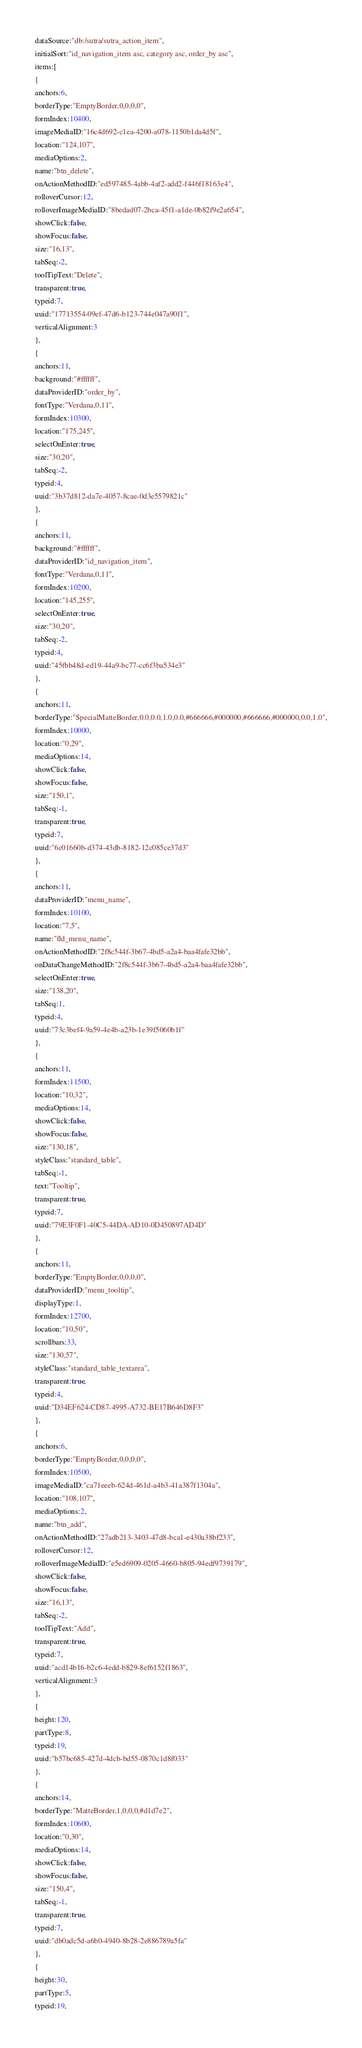Convert code to text. <code><loc_0><loc_0><loc_500><loc_500><_VisualBasic_>dataSource:"db:/sutra/sutra_action_item",
initialSort:"id_navigation_item asc, category asc, order_by asc",
items:[
{
anchors:6,
borderType:"EmptyBorder,0,0,0,0",
formIndex:10400,
imageMediaID:"16c4d692-c1ea-4200-a078-1150b1da4d5f",
location:"124,107",
mediaOptions:2,
name:"btn_delete",
onActionMethodID:"ed597485-4abb-4af2-add2-f446f18163e4",
rolloverCursor:12,
rolloverImageMediaID:"8bedad07-2bca-45f1-a1de-0b82f9e2a654",
showClick:false,
showFocus:false,
size:"16,13",
tabSeq:-2,
toolTipText:"Delete",
transparent:true,
typeid:7,
uuid:"17713554-09ef-47d6-b123-744e047a90f1",
verticalAlignment:3
},
{
anchors:11,
background:"#ffffff",
dataProviderID:"order_by",
fontType:"Verdana,0,11",
formIndex:10300,
location:"175,245",
selectOnEnter:true,
size:"30,20",
tabSeq:-2,
typeid:4,
uuid:"3b37d812-da7e-4057-8cae-0d3e5579821c"
},
{
anchors:11,
background:"#ffffff",
dataProviderID:"id_navigation_item",
fontType:"Verdana,0,11",
formIndex:10200,
location:"145,255",
selectOnEnter:true,
size:"30,20",
tabSeq:-2,
typeid:4,
uuid:"45fbb48d-ed19-44a9-bc77-cc6f3ba534e3"
},
{
anchors:11,
borderType:"SpecialMatteBorder,0.0,0.0,1.0,0.0,#666666,#000000,#666666,#000000,0.0,1.0",
formIndex:10000,
location:"0,29",
mediaOptions:14,
showClick:false,
showFocus:false,
size:"150,1",
tabSeq:-1,
transparent:true,
typeid:7,
uuid:"6c01660b-d374-43db-8182-12c085ce37d3"
},
{
anchors:11,
dataProviderID:"menu_name",
formIndex:10100,
location:"7,5",
name:"fld_menu_name",
onActionMethodID:"2f8c544f-3b67-4bd5-a2a4-baa4fafe32bb",
onDataChangeMethodID:"2f8c544f-3b67-4bd5-a2a4-baa4fafe32bb",
selectOnEnter:true,
size:"138,20",
tabSeq:1,
typeid:4,
uuid:"73c3bef4-9a59-4e4b-a23b-1e39f5060b1f"
},
{
anchors:11,
formIndex:11500,
location:"10,32",
mediaOptions:14,
showClick:false,
showFocus:false,
size:"130,18",
styleClass:"standard_table",
tabSeq:-1,
text:"Tooltip",
transparent:true,
typeid:7,
uuid:"79E3F0F1-40C5-44DA-AD10-0D450897AD4D"
},
{
anchors:11,
borderType:"EmptyBorder,0,0,0,0",
dataProviderID:"menu_tooltip",
displayType:1,
formIndex:12700,
location:"10,50",
scrollbars:33,
size:"130,57",
styleClass:"standard_table_textarea",
transparent:true,
typeid:4,
uuid:"D34EF624-CD87-4995-A732-BE17B646D8F3"
},
{
anchors:6,
borderType:"EmptyBorder,0,0,0,0",
formIndex:10500,
imageMediaID:"ca71eeeb-624d-461d-a4b3-41a387f1304a",
location:"108,107",
mediaOptions:2,
name:"btn_add",
onActionMethodID:"27adb213-3403-47d8-bca1-e430a38bf233",
rolloverCursor:12,
rolloverImageMediaID:"e5ed6909-0205-4660-b805-94edf9739179",
showClick:false,
showFocus:false,
size:"16,13",
tabSeq:-2,
toolTipText:"Add",
transparent:true,
typeid:7,
uuid:"acd14b16-b2c6-4edd-b829-8ef6152f1863",
verticalAlignment:3
},
{
height:120,
partType:8,
typeid:19,
uuid:"b57bc685-427d-4dcb-bd55-0870c1d8f033"
},
{
anchors:14,
borderType:"MatteBorder,1,0,0,0,#d1d7e2",
formIndex:10600,
location:"0,30",
mediaOptions:14,
showClick:false,
showFocus:false,
size:"150,4",
tabSeq:-1,
transparent:true,
typeid:7,
uuid:"db0adc5d-a6b0-4940-8b28-2e886789a5fa"
},
{
height:30,
partType:5,
typeid:19,</code> 